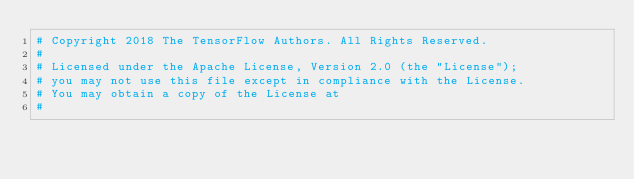Convert code to text. <code><loc_0><loc_0><loc_500><loc_500><_Python_># Copyright 2018 The TensorFlow Authors. All Rights Reserved.
#
# Licensed under the Apache License, Version 2.0 (the "License");
# you may not use this file except in compliance with the License.
# You may obtain a copy of the License at
#</code> 